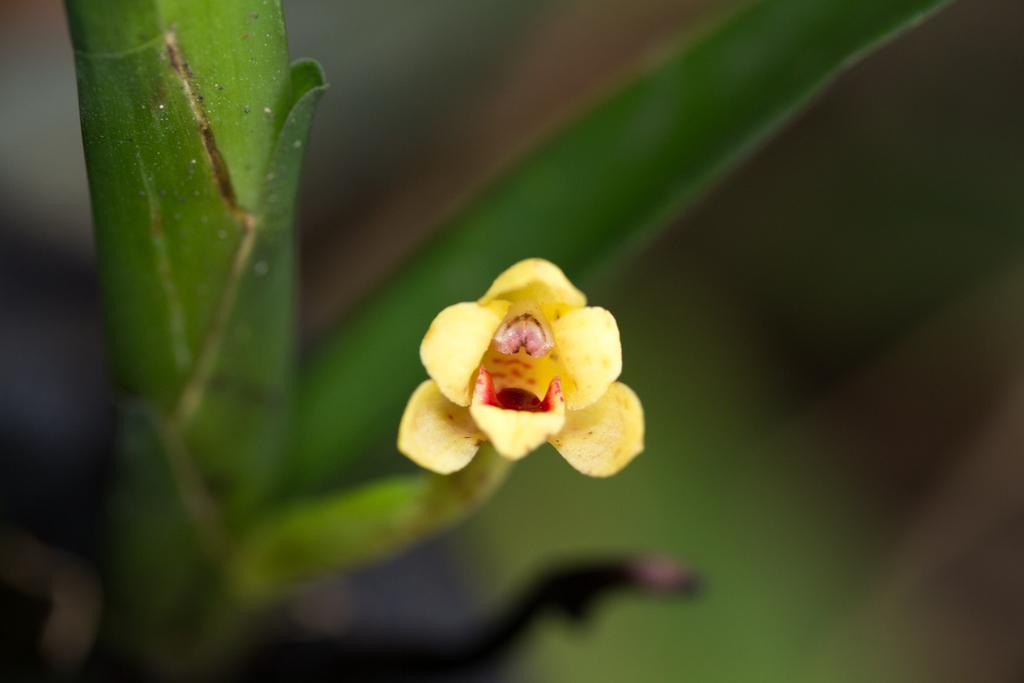What is the main subject of the image? The main subject of the image is a flower. Can you describe the color of the flower? The flower is yellow in color. Is the flower part of a larger structure? Yes, the flower is part of a branch. How would you describe the background of the image? The background of the image is blurred. How many goldfish are swimming in the image? There are no goldfish present in the image; it features a yellow flower on a branch. What type of knee injury is visible in the image? There is no knee injury present in the image; it features a yellow flower on a branch. 